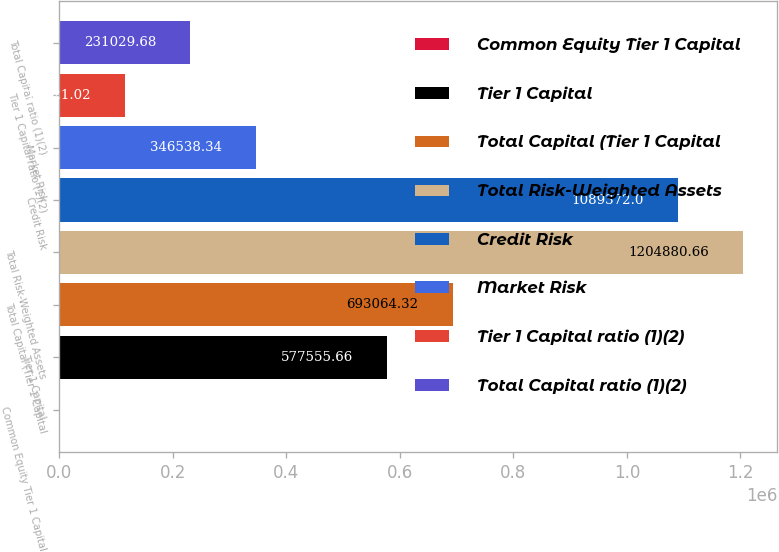<chart> <loc_0><loc_0><loc_500><loc_500><bar_chart><fcel>Common Equity Tier 1 Capital<fcel>Tier 1 Capital<fcel>Total Capital (Tier 1 Capital<fcel>Total Risk-Weighted Assets<fcel>Credit Risk<fcel>Market Risk<fcel>Tier 1 Capital ratio (1)(2)<fcel>Total Capital ratio (1)(2)<nl><fcel>12.36<fcel>577556<fcel>693064<fcel>1.20488e+06<fcel>1.08937e+06<fcel>346538<fcel>115521<fcel>231030<nl></chart> 